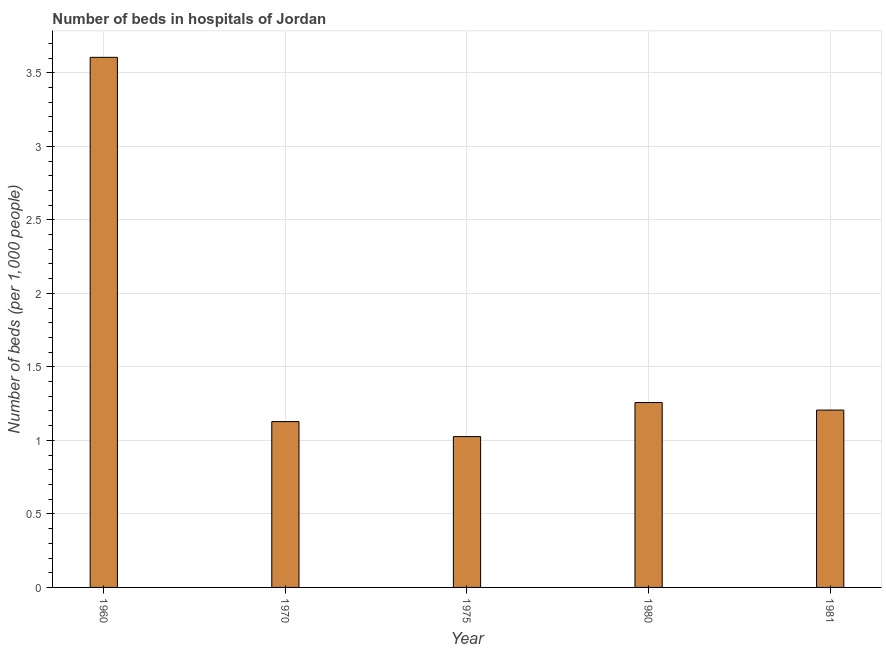What is the title of the graph?
Give a very brief answer. Number of beds in hospitals of Jordan. What is the label or title of the X-axis?
Make the answer very short. Year. What is the label or title of the Y-axis?
Provide a short and direct response. Number of beds (per 1,0 people). What is the number of hospital beds in 1975?
Ensure brevity in your answer.  1.03. Across all years, what is the maximum number of hospital beds?
Your response must be concise. 3.61. Across all years, what is the minimum number of hospital beds?
Your answer should be very brief. 1.03. In which year was the number of hospital beds maximum?
Offer a terse response. 1960. In which year was the number of hospital beds minimum?
Offer a very short reply. 1975. What is the sum of the number of hospital beds?
Keep it short and to the point. 8.22. What is the difference between the number of hospital beds in 1960 and 1981?
Give a very brief answer. 2.4. What is the average number of hospital beds per year?
Offer a very short reply. 1.65. What is the median number of hospital beds?
Offer a terse response. 1.21. In how many years, is the number of hospital beds greater than 1 %?
Your answer should be very brief. 5. What is the ratio of the number of hospital beds in 1975 to that in 1981?
Offer a terse response. 0.85. Is the number of hospital beds in 1960 less than that in 1981?
Keep it short and to the point. No. What is the difference between the highest and the second highest number of hospital beds?
Offer a terse response. 2.35. What is the difference between the highest and the lowest number of hospital beds?
Offer a terse response. 2.58. Are all the bars in the graph horizontal?
Your answer should be very brief. No. Are the values on the major ticks of Y-axis written in scientific E-notation?
Give a very brief answer. No. What is the Number of beds (per 1,000 people) of 1960?
Offer a terse response. 3.61. What is the Number of beds (per 1,000 people) of 1970?
Make the answer very short. 1.13. What is the Number of beds (per 1,000 people) in 1975?
Keep it short and to the point. 1.03. What is the Number of beds (per 1,000 people) in 1980?
Your response must be concise. 1.26. What is the Number of beds (per 1,000 people) of 1981?
Offer a very short reply. 1.21. What is the difference between the Number of beds (per 1,000 people) in 1960 and 1970?
Give a very brief answer. 2.48. What is the difference between the Number of beds (per 1,000 people) in 1960 and 1975?
Ensure brevity in your answer.  2.58. What is the difference between the Number of beds (per 1,000 people) in 1960 and 1980?
Keep it short and to the point. 2.35. What is the difference between the Number of beds (per 1,000 people) in 1960 and 1981?
Your answer should be compact. 2.4. What is the difference between the Number of beds (per 1,000 people) in 1970 and 1975?
Provide a short and direct response. 0.1. What is the difference between the Number of beds (per 1,000 people) in 1970 and 1980?
Your response must be concise. -0.13. What is the difference between the Number of beds (per 1,000 people) in 1970 and 1981?
Give a very brief answer. -0.08. What is the difference between the Number of beds (per 1,000 people) in 1975 and 1980?
Your answer should be very brief. -0.23. What is the difference between the Number of beds (per 1,000 people) in 1975 and 1981?
Provide a succinct answer. -0.18. What is the difference between the Number of beds (per 1,000 people) in 1980 and 1981?
Keep it short and to the point. 0.05. What is the ratio of the Number of beds (per 1,000 people) in 1960 to that in 1970?
Offer a terse response. 3.2. What is the ratio of the Number of beds (per 1,000 people) in 1960 to that in 1975?
Provide a short and direct response. 3.51. What is the ratio of the Number of beds (per 1,000 people) in 1960 to that in 1980?
Ensure brevity in your answer.  2.87. What is the ratio of the Number of beds (per 1,000 people) in 1960 to that in 1981?
Give a very brief answer. 2.99. What is the ratio of the Number of beds (per 1,000 people) in 1970 to that in 1975?
Provide a short and direct response. 1.1. What is the ratio of the Number of beds (per 1,000 people) in 1970 to that in 1980?
Offer a terse response. 0.9. What is the ratio of the Number of beds (per 1,000 people) in 1970 to that in 1981?
Make the answer very short. 0.94. What is the ratio of the Number of beds (per 1,000 people) in 1975 to that in 1980?
Make the answer very short. 0.82. What is the ratio of the Number of beds (per 1,000 people) in 1975 to that in 1981?
Keep it short and to the point. 0.85. What is the ratio of the Number of beds (per 1,000 people) in 1980 to that in 1981?
Provide a short and direct response. 1.04. 